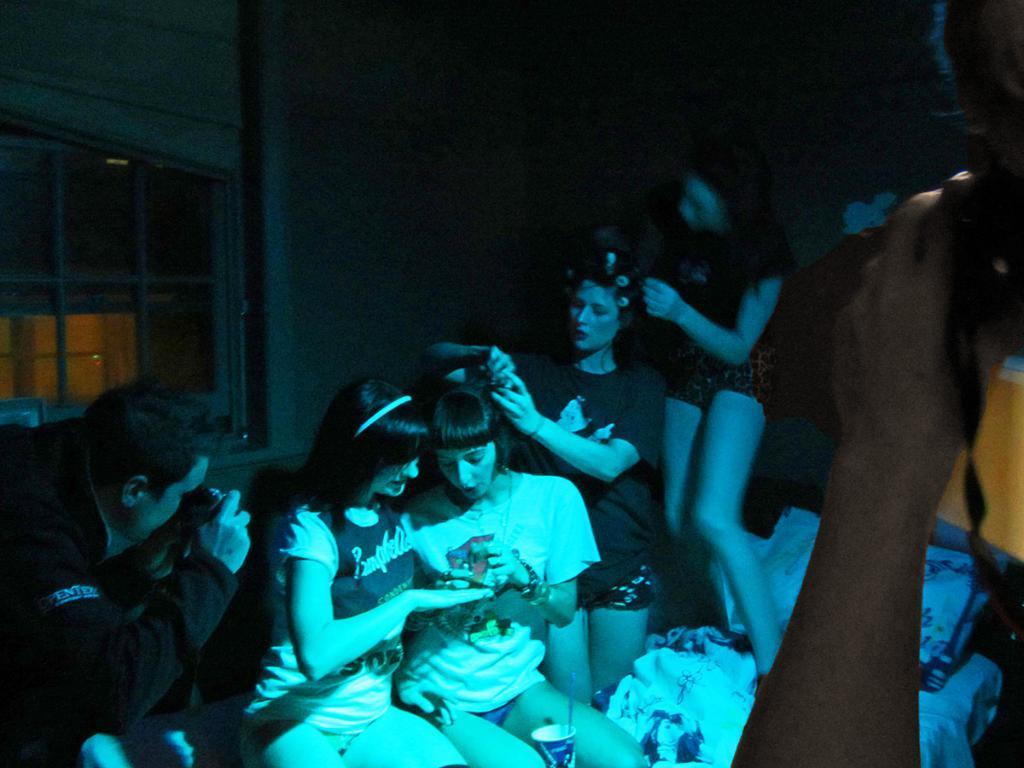How would you summarize this image in a sentence or two? This picture describes about group of people, few are seated and few are standing, on the left side of the image we can see a man, he is holding a camera. 